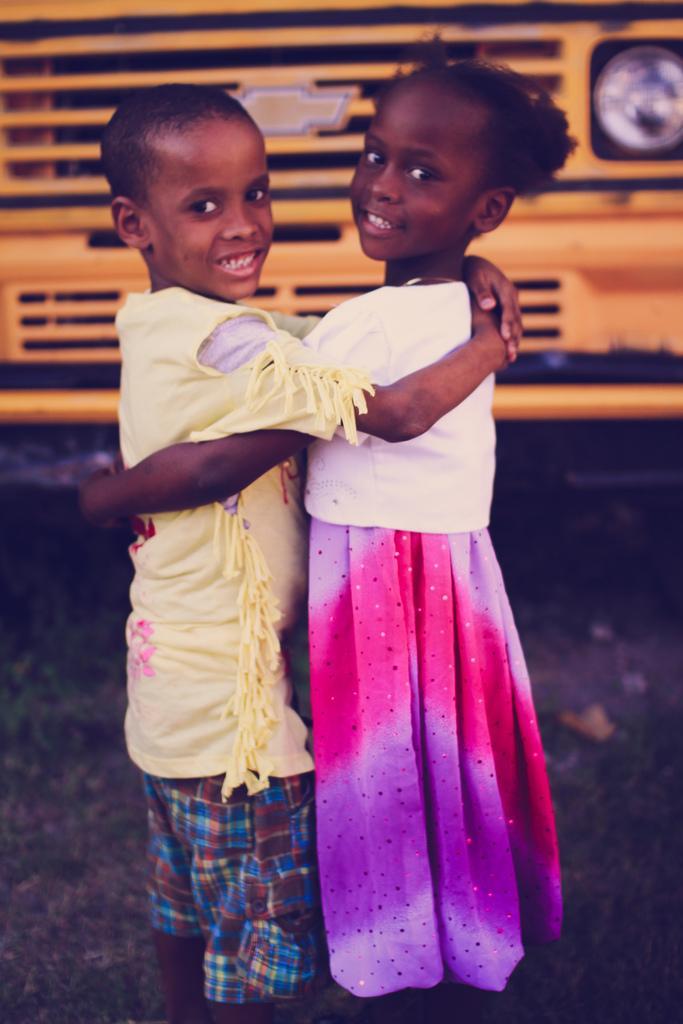Can you describe this image briefly? This image consists of two kids. At the bottom, there is a road. In the background, we can see a bus in yellow color. 